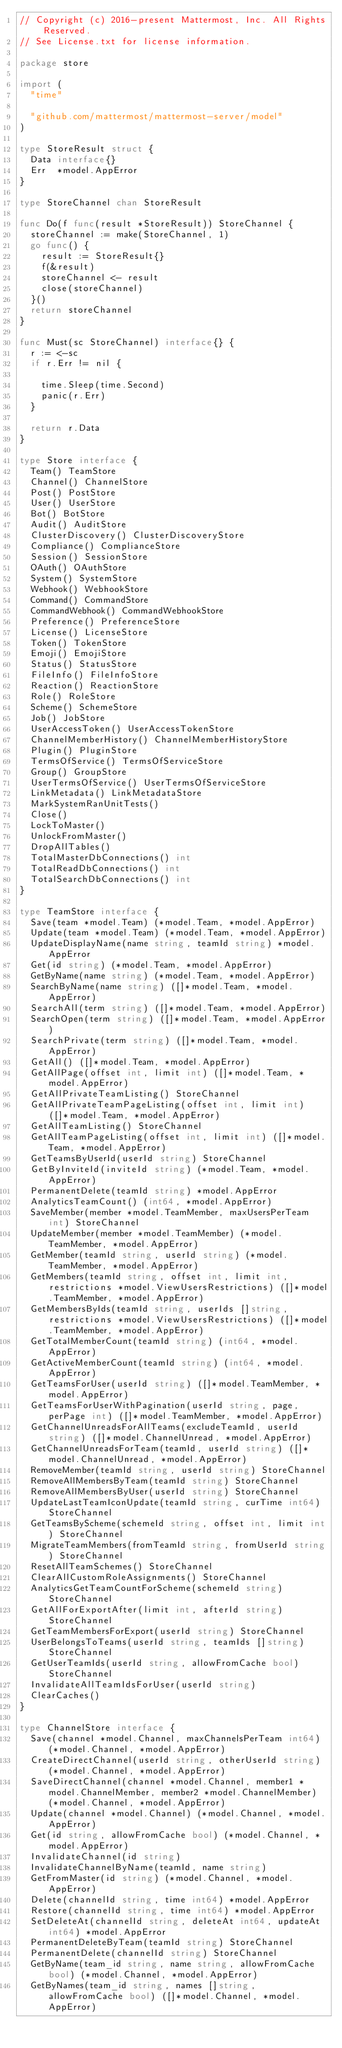<code> <loc_0><loc_0><loc_500><loc_500><_Go_>// Copyright (c) 2016-present Mattermost, Inc. All Rights Reserved.
// See License.txt for license information.

package store

import (
	"time"

	"github.com/mattermost/mattermost-server/model"
)

type StoreResult struct {
	Data interface{}
	Err  *model.AppError
}

type StoreChannel chan StoreResult

func Do(f func(result *StoreResult)) StoreChannel {
	storeChannel := make(StoreChannel, 1)
	go func() {
		result := StoreResult{}
		f(&result)
		storeChannel <- result
		close(storeChannel)
	}()
	return storeChannel
}

func Must(sc StoreChannel) interface{} {
	r := <-sc
	if r.Err != nil {

		time.Sleep(time.Second)
		panic(r.Err)
	}

	return r.Data
}

type Store interface {
	Team() TeamStore
	Channel() ChannelStore
	Post() PostStore
	User() UserStore
	Bot() BotStore
	Audit() AuditStore
	ClusterDiscovery() ClusterDiscoveryStore
	Compliance() ComplianceStore
	Session() SessionStore
	OAuth() OAuthStore
	System() SystemStore
	Webhook() WebhookStore
	Command() CommandStore
	CommandWebhook() CommandWebhookStore
	Preference() PreferenceStore
	License() LicenseStore
	Token() TokenStore
	Emoji() EmojiStore
	Status() StatusStore
	FileInfo() FileInfoStore
	Reaction() ReactionStore
	Role() RoleStore
	Scheme() SchemeStore
	Job() JobStore
	UserAccessToken() UserAccessTokenStore
	ChannelMemberHistory() ChannelMemberHistoryStore
	Plugin() PluginStore
	TermsOfService() TermsOfServiceStore
	Group() GroupStore
	UserTermsOfService() UserTermsOfServiceStore
	LinkMetadata() LinkMetadataStore
	MarkSystemRanUnitTests()
	Close()
	LockToMaster()
	UnlockFromMaster()
	DropAllTables()
	TotalMasterDbConnections() int
	TotalReadDbConnections() int
	TotalSearchDbConnections() int
}

type TeamStore interface {
	Save(team *model.Team) (*model.Team, *model.AppError)
	Update(team *model.Team) (*model.Team, *model.AppError)
	UpdateDisplayName(name string, teamId string) *model.AppError
	Get(id string) (*model.Team, *model.AppError)
	GetByName(name string) (*model.Team, *model.AppError)
	SearchByName(name string) ([]*model.Team, *model.AppError)
	SearchAll(term string) ([]*model.Team, *model.AppError)
	SearchOpen(term string) ([]*model.Team, *model.AppError)
	SearchPrivate(term string) ([]*model.Team, *model.AppError)
	GetAll() ([]*model.Team, *model.AppError)
	GetAllPage(offset int, limit int) ([]*model.Team, *model.AppError)
	GetAllPrivateTeamListing() StoreChannel
	GetAllPrivateTeamPageListing(offset int, limit int) ([]*model.Team, *model.AppError)
	GetAllTeamListing() StoreChannel
	GetAllTeamPageListing(offset int, limit int) ([]*model.Team, *model.AppError)
	GetTeamsByUserId(userId string) StoreChannel
	GetByInviteId(inviteId string) (*model.Team, *model.AppError)
	PermanentDelete(teamId string) *model.AppError
	AnalyticsTeamCount() (int64, *model.AppError)
	SaveMember(member *model.TeamMember, maxUsersPerTeam int) StoreChannel
	UpdateMember(member *model.TeamMember) (*model.TeamMember, *model.AppError)
	GetMember(teamId string, userId string) (*model.TeamMember, *model.AppError)
	GetMembers(teamId string, offset int, limit int, restrictions *model.ViewUsersRestrictions) ([]*model.TeamMember, *model.AppError)
	GetMembersByIds(teamId string, userIds []string, restrictions *model.ViewUsersRestrictions) ([]*model.TeamMember, *model.AppError)
	GetTotalMemberCount(teamId string) (int64, *model.AppError)
	GetActiveMemberCount(teamId string) (int64, *model.AppError)
	GetTeamsForUser(userId string) ([]*model.TeamMember, *model.AppError)
	GetTeamsForUserWithPagination(userId string, page, perPage int) ([]*model.TeamMember, *model.AppError)
	GetChannelUnreadsForAllTeams(excludeTeamId, userId string) ([]*model.ChannelUnread, *model.AppError)
	GetChannelUnreadsForTeam(teamId, userId string) ([]*model.ChannelUnread, *model.AppError)
	RemoveMember(teamId string, userId string) StoreChannel
	RemoveAllMembersByTeam(teamId string) StoreChannel
	RemoveAllMembersByUser(userId string) StoreChannel
	UpdateLastTeamIconUpdate(teamId string, curTime int64) StoreChannel
	GetTeamsByScheme(schemeId string, offset int, limit int) StoreChannel
	MigrateTeamMembers(fromTeamId string, fromUserId string) StoreChannel
	ResetAllTeamSchemes() StoreChannel
	ClearAllCustomRoleAssignments() StoreChannel
	AnalyticsGetTeamCountForScheme(schemeId string) StoreChannel
	GetAllForExportAfter(limit int, afterId string) StoreChannel
	GetTeamMembersForExport(userId string) StoreChannel
	UserBelongsToTeams(userId string, teamIds []string) StoreChannel
	GetUserTeamIds(userId string, allowFromCache bool) StoreChannel
	InvalidateAllTeamIdsForUser(userId string)
	ClearCaches()
}

type ChannelStore interface {
	Save(channel *model.Channel, maxChannelsPerTeam int64) (*model.Channel, *model.AppError)
	CreateDirectChannel(userId string, otherUserId string) (*model.Channel, *model.AppError)
	SaveDirectChannel(channel *model.Channel, member1 *model.ChannelMember, member2 *model.ChannelMember) (*model.Channel, *model.AppError)
	Update(channel *model.Channel) (*model.Channel, *model.AppError)
	Get(id string, allowFromCache bool) (*model.Channel, *model.AppError)
	InvalidateChannel(id string)
	InvalidateChannelByName(teamId, name string)
	GetFromMaster(id string) (*model.Channel, *model.AppError)
	Delete(channelId string, time int64) *model.AppError
	Restore(channelId string, time int64) *model.AppError
	SetDeleteAt(channelId string, deleteAt int64, updateAt int64) *model.AppError
	PermanentDeleteByTeam(teamId string) StoreChannel
	PermanentDelete(channelId string) StoreChannel
	GetByName(team_id string, name string, allowFromCache bool) (*model.Channel, *model.AppError)
	GetByNames(team_id string, names []string, allowFromCache bool) ([]*model.Channel, *model.AppError)</code> 